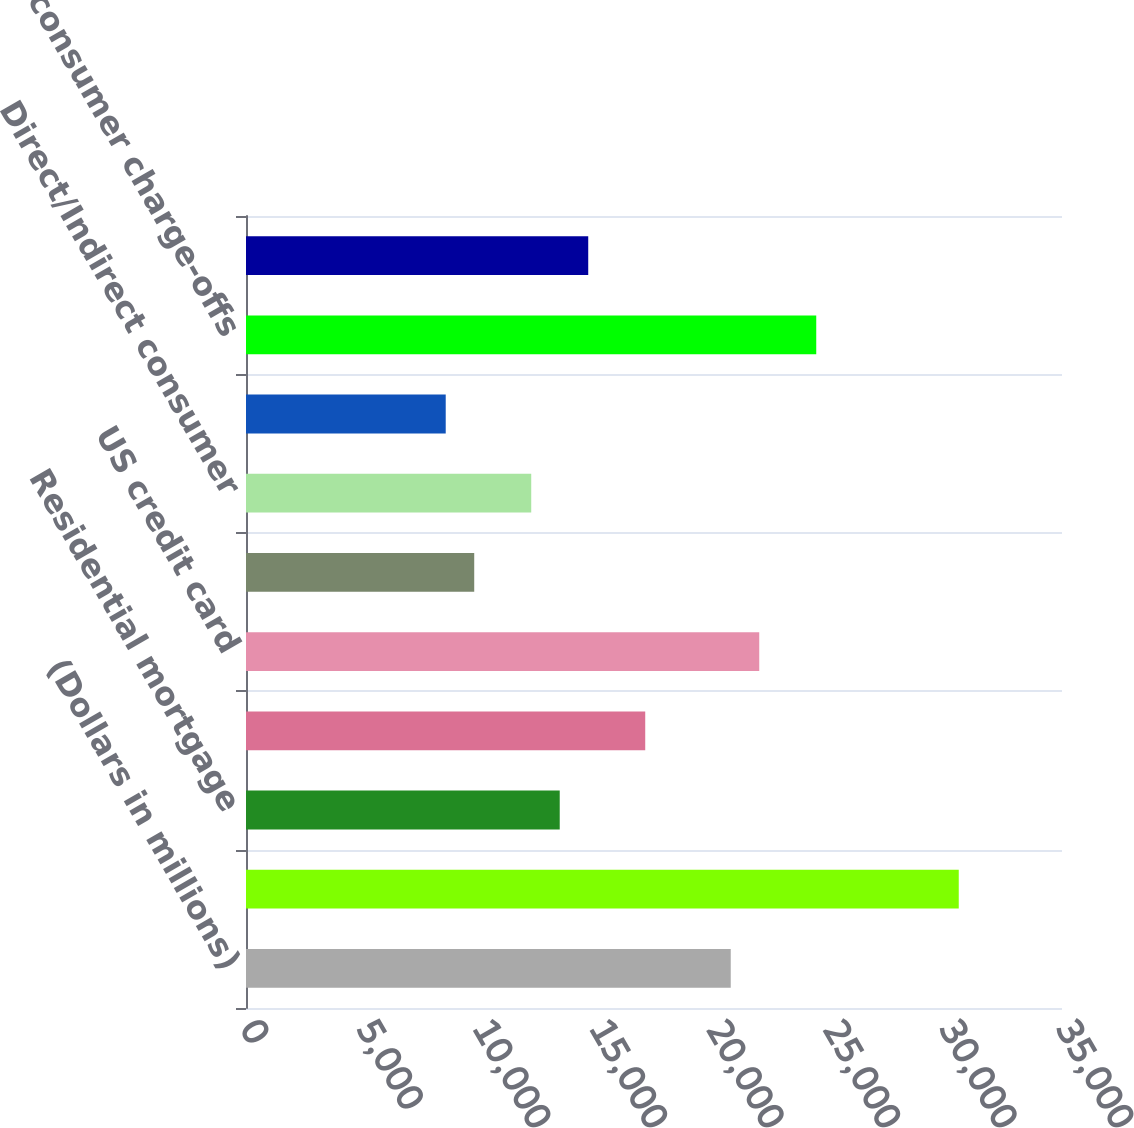<chart> <loc_0><loc_0><loc_500><loc_500><bar_chart><fcel>(Dollars in millions)<fcel>Allowance for loan and lease<fcel>Residential mortgage<fcel>Home equity<fcel>US credit card<fcel>Non-US credit card (1)<fcel>Direct/Indirect consumer<fcel>Other consumer<fcel>Total consumer charge-offs<fcel>US commercial (2)<nl><fcel>20791.5<fcel>30571.5<fcel>13456.5<fcel>17124<fcel>22014<fcel>9789<fcel>12234<fcel>8566.5<fcel>24459<fcel>14679<nl></chart> 